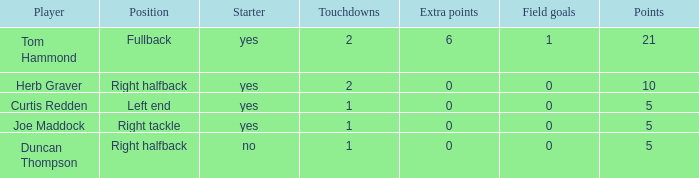Name the most touchdowns for field goals being 1 2.0. 